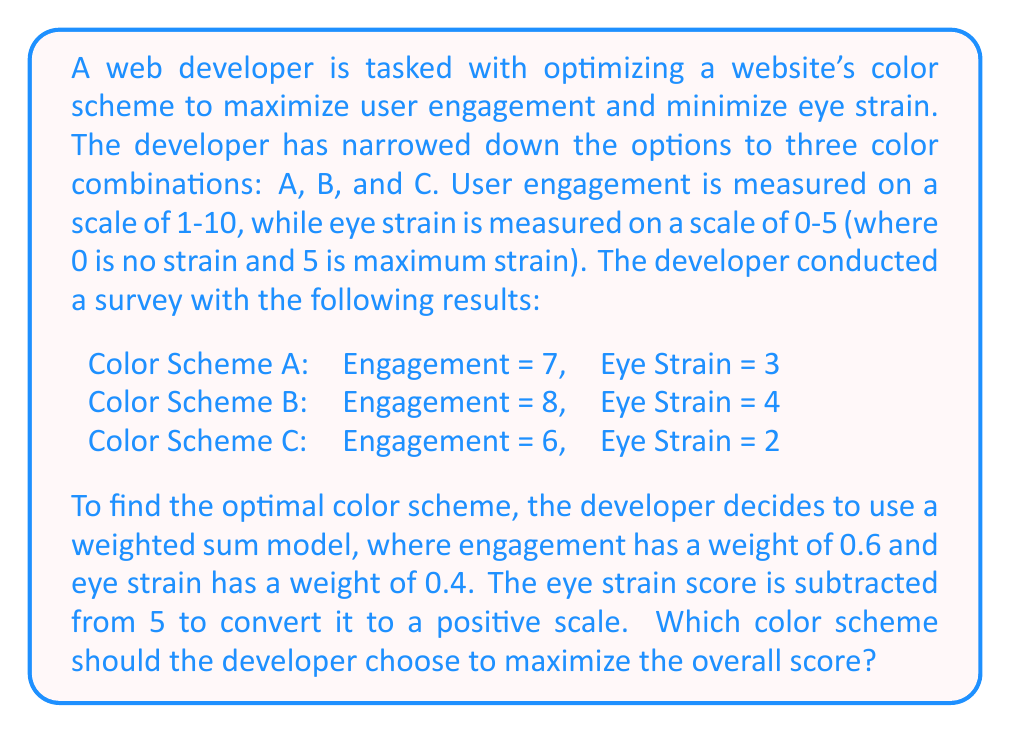Help me with this question. To solve this problem, we need to follow these steps:

1. Convert the eye strain score to a positive scale by subtracting it from 5.
2. Calculate the weighted sum for each color scheme using the formula:
   $$\text{Score} = 0.6 \times \text{Engagement} + 0.4 \times (5 - \text{Eye Strain})$$
3. Compare the scores and choose the highest one.

Let's calculate the score for each color scheme:

Color Scheme A:
$$\begin{align*}
\text{Score}_A &= 0.6 \times 7 + 0.4 \times (5 - 3) \\
&= 4.2 + 0.8 \\
&= 5.0
\end{align*}$$

Color Scheme B:
$$\begin{align*}
\text{Score}_B &= 0.6 \times 8 + 0.4 \times (5 - 4) \\
&= 4.8 + 0.4 \\
&= 5.2
\end{align*}$$

Color Scheme C:
$$\begin{align*}
\text{Score}_C &= 0.6 \times 6 + 0.4 \times (5 - 2) \\
&= 3.6 + 1.2 \\
&= 4.8
\end{align*}$$

Comparing the scores:
$$\text{Score}_B (5.2) > \text{Score}_A (5.0) > \text{Score}_C (4.8)$$

Therefore, Color Scheme B has the highest overall score and should be chosen as the optimal color scheme.
Answer: The developer should choose Color Scheme B, which has the highest overall score of 5.2. 